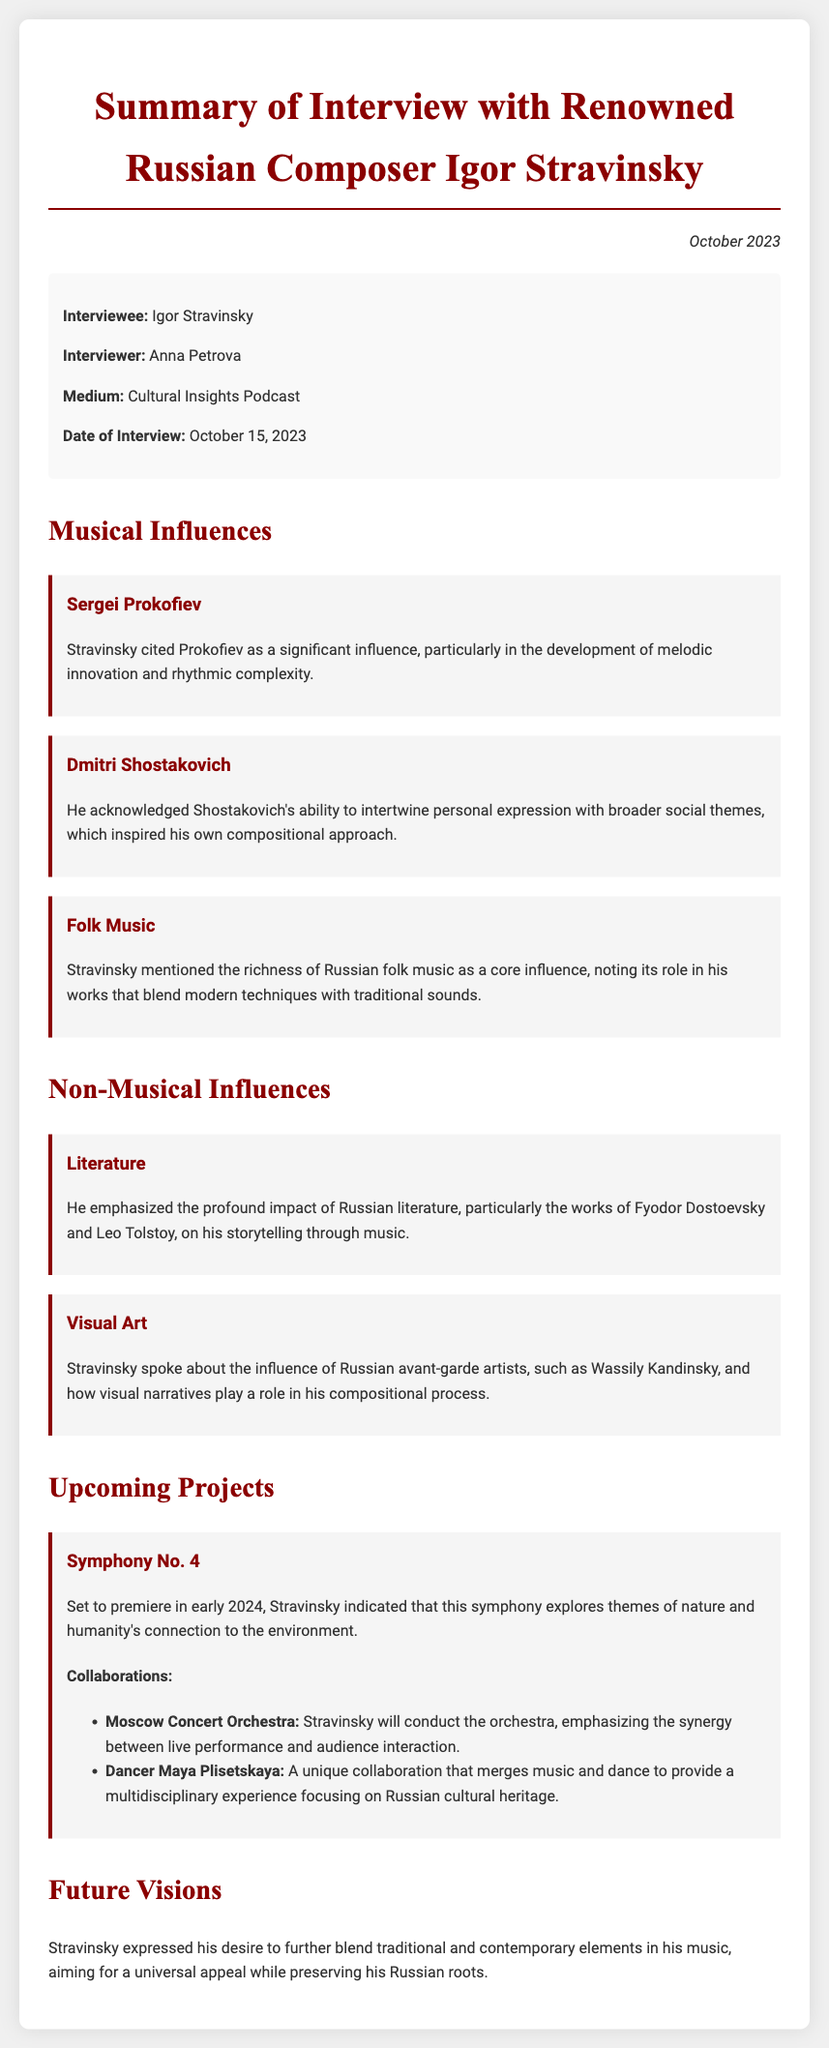What is the name of the composer interviewed? The document identifies Igor Stravinsky as the composer interviewed.
Answer: Igor Stravinsky Who conducted the interview? The memo states that Anna Petrova was the interviewer.
Answer: Anna Petrova When was the interview conducted? The document mentions that the interview took place on October 15, 2023.
Answer: October 15, 2023 Which musical influence is mentioned first? The first musical influence discussed in the document is Sergei Prokofiev.
Answer: Sergei Prokofiev What is the title of Stravinsky's upcoming project? The memo indicates that Stravinsky's upcoming project is Symphony No. 4.
Answer: Symphony No. 4 What themes does Symphony No. 4 explore? The document states that Symphony No. 4 explores themes of nature and humanity's connection to the environment.
Answer: Themes of nature and humanity's connection to the environment Who will conduct the Moscow Concert Orchestra? The memo specifies that Stravinsky will conduct the Moscow Concert Orchestra.
Answer: Stravinsky Which dancer is mentioned as a collaborator on the upcoming project? The document highlights dancer Maya Plisetskaya as a collaborator.
Answer: Maya Plisetskaya What impact did Russian literature have on Stravinsky's work? The memo states that Russian literature profoundly impacted Stravinsky's storytelling through music.
Answer: Storytelling through music 